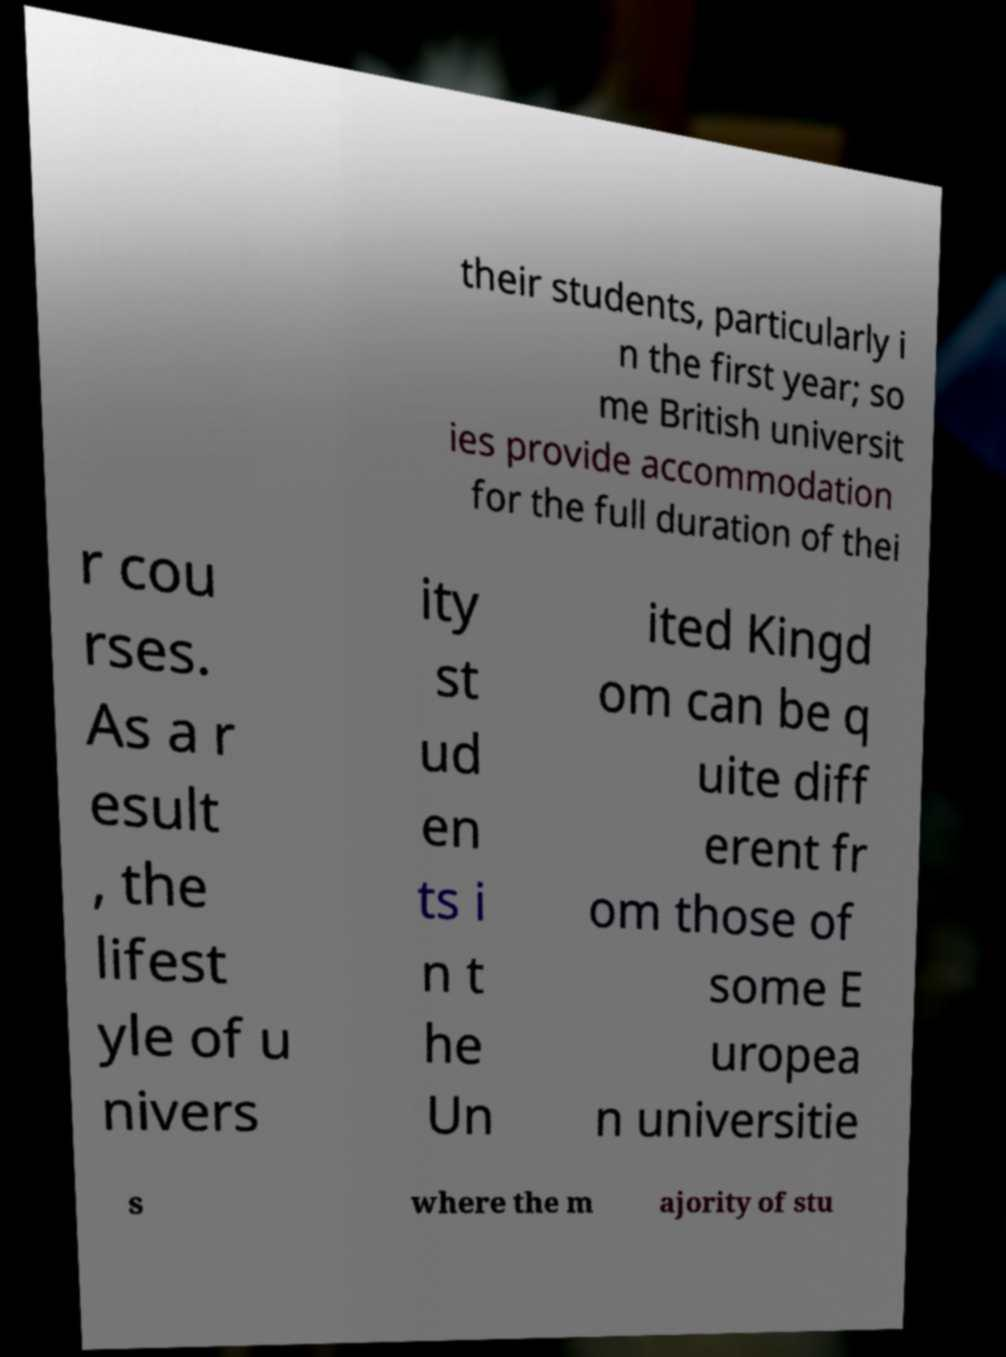Can you accurately transcribe the text from the provided image for me? their students, particularly i n the first year; so me British universit ies provide accommodation for the full duration of thei r cou rses. As a r esult , the lifest yle of u nivers ity st ud en ts i n t he Un ited Kingd om can be q uite diff erent fr om those of some E uropea n universitie s where the m ajority of stu 